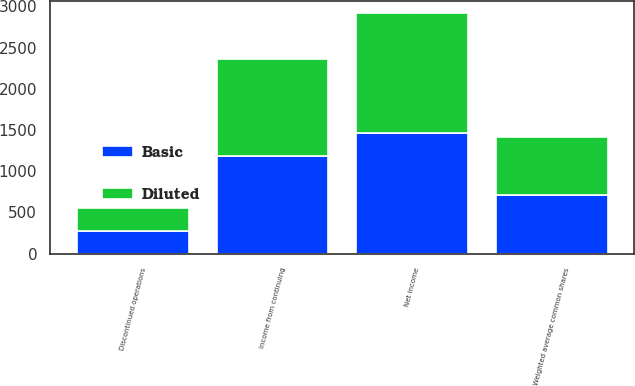<chart> <loc_0><loc_0><loc_500><loc_500><stacked_bar_chart><ecel><fcel>Income from continuing<fcel>Discontinued operations<fcel>Net income<fcel>Weighted average common shares<nl><fcel>Basic<fcel>1184<fcel>279<fcel>1463<fcel>709<nl><fcel>Diluted<fcel>1184<fcel>279<fcel>1463<fcel>711<nl></chart> 